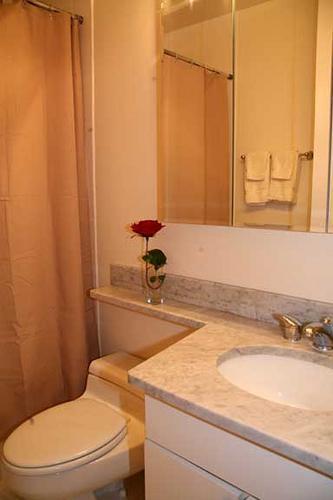How many black umbrellas are there?
Give a very brief answer. 0. 